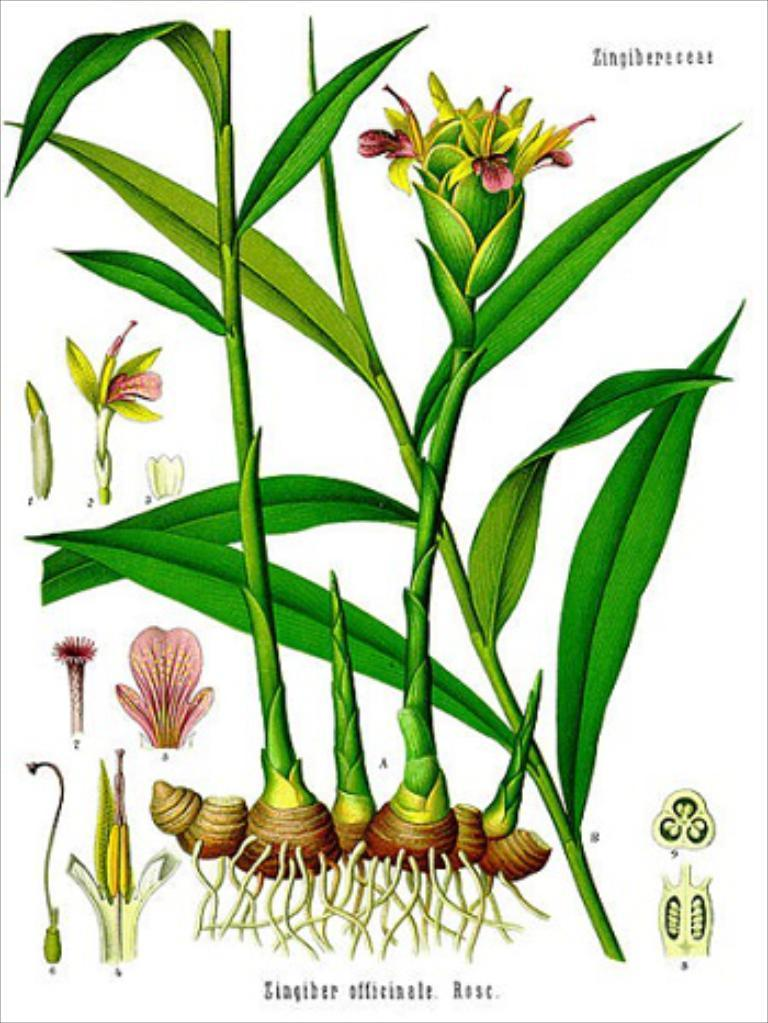What type of art is featured in the image? The image contains digital art of plants. What color are the plants in the image? The plants are green in color. What other elements can be seen in the image besides the plants? There are flowers in the image. What color are the flowers in the image? The flowers are pink in color. What is the background color of the image? The background of the image is white. Are there any icicles visible in the image? No, there are no icicles present in the image. Does the image depict a scene at night? No, the image does not depict a night scene; the background is white. 